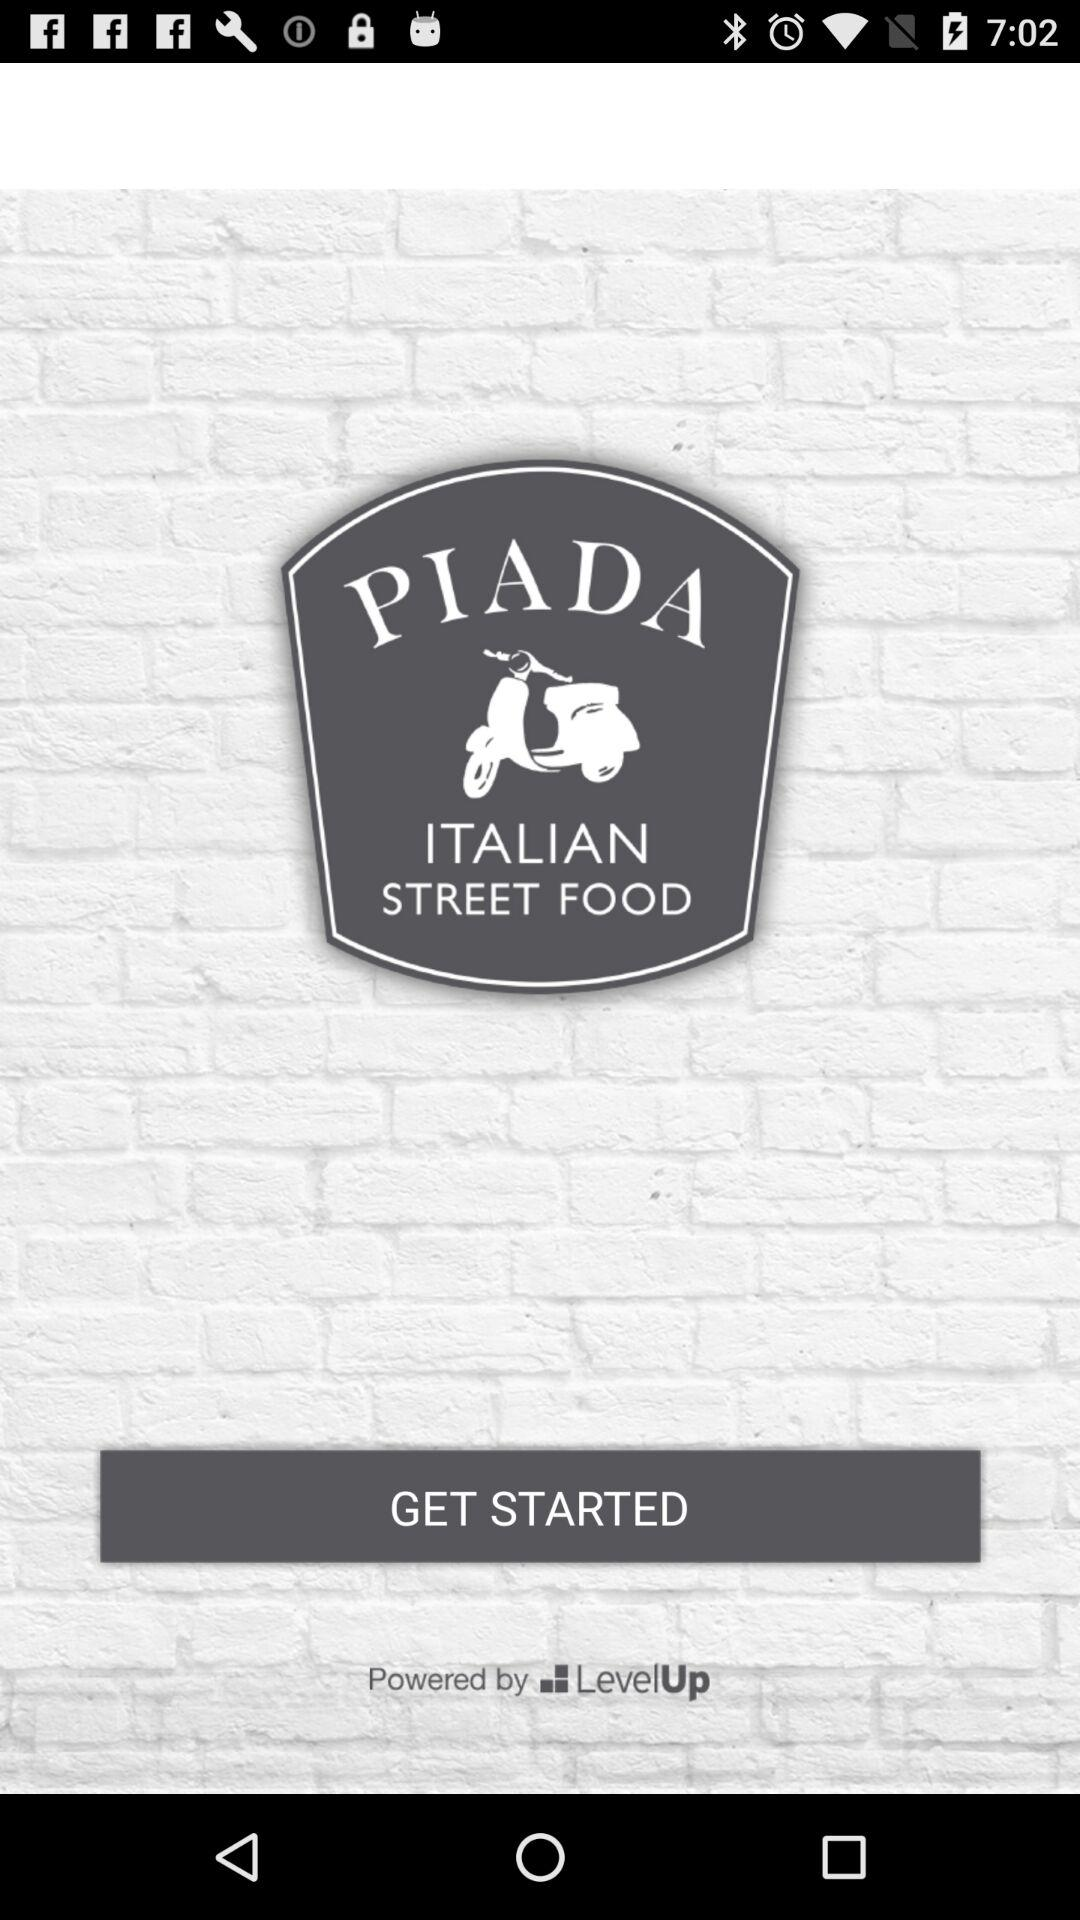What is the application name? The application name is "PIADA". 